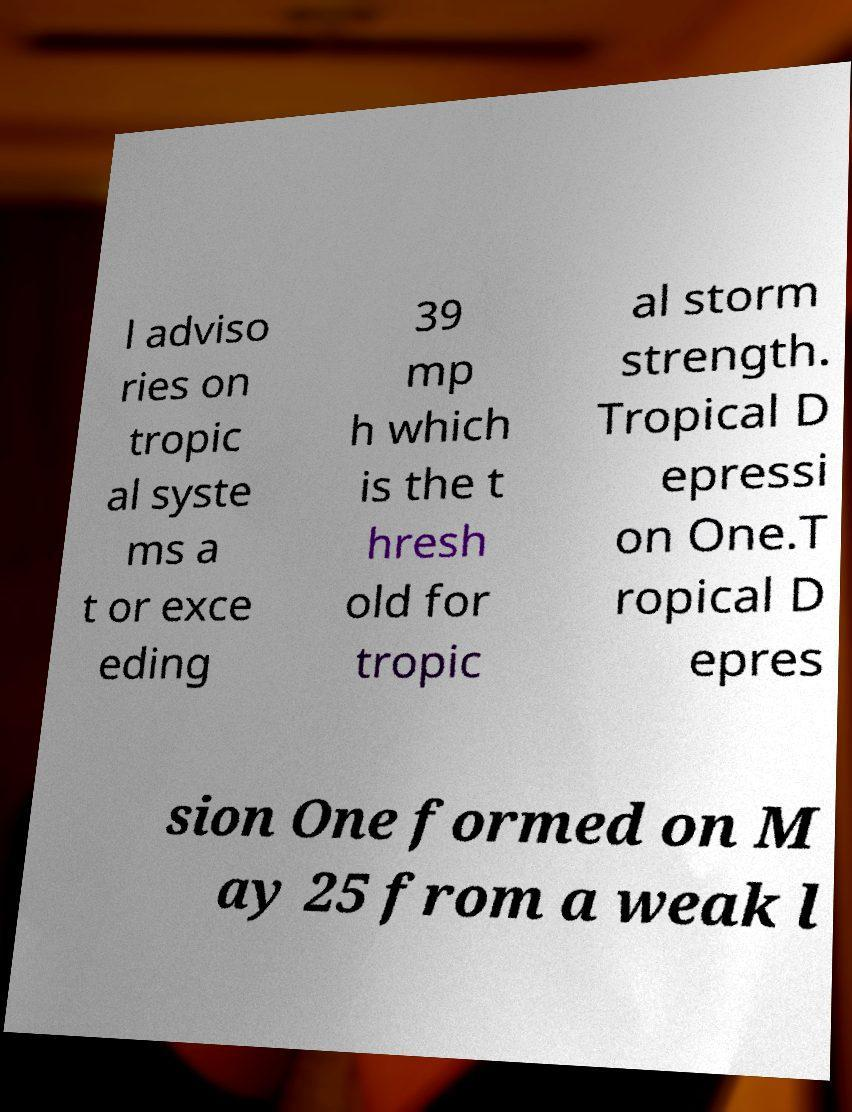Can you read and provide the text displayed in the image?This photo seems to have some interesting text. Can you extract and type it out for me? l adviso ries on tropic al syste ms a t or exce eding 39 mp h which is the t hresh old for tropic al storm strength. Tropical D epressi on One.T ropical D epres sion One formed on M ay 25 from a weak l 